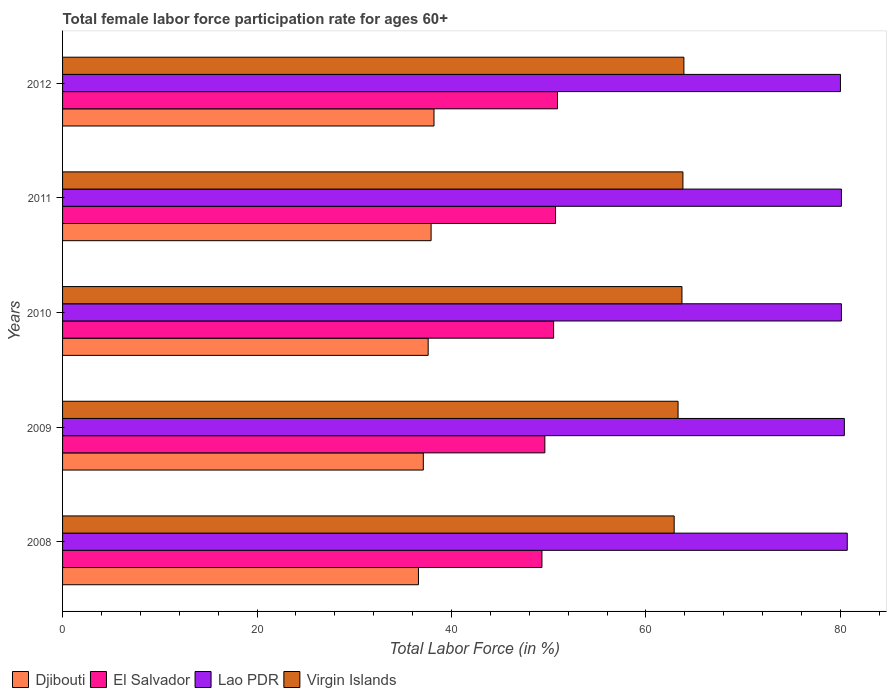How many groups of bars are there?
Ensure brevity in your answer.  5. Are the number of bars per tick equal to the number of legend labels?
Provide a succinct answer. Yes. What is the label of the 3rd group of bars from the top?
Give a very brief answer. 2010. What is the female labor force participation rate in Djibouti in 2009?
Make the answer very short. 37.1. Across all years, what is the maximum female labor force participation rate in Lao PDR?
Ensure brevity in your answer.  80.7. Across all years, what is the minimum female labor force participation rate in Virgin Islands?
Provide a short and direct response. 62.9. What is the total female labor force participation rate in Virgin Islands in the graph?
Ensure brevity in your answer.  317.6. What is the difference between the female labor force participation rate in El Salvador in 2010 and the female labor force participation rate in Lao PDR in 2009?
Make the answer very short. -29.9. What is the average female labor force participation rate in Djibouti per year?
Make the answer very short. 37.48. In the year 2009, what is the difference between the female labor force participation rate in Djibouti and female labor force participation rate in El Salvador?
Ensure brevity in your answer.  -12.5. What is the ratio of the female labor force participation rate in El Salvador in 2009 to that in 2012?
Your answer should be compact. 0.97. Is the female labor force participation rate in El Salvador in 2008 less than that in 2012?
Ensure brevity in your answer.  Yes. Is the difference between the female labor force participation rate in Djibouti in 2008 and 2011 greater than the difference between the female labor force participation rate in El Salvador in 2008 and 2011?
Ensure brevity in your answer.  Yes. What is the difference between the highest and the second highest female labor force participation rate in Djibouti?
Offer a very short reply. 0.3. What is the difference between the highest and the lowest female labor force participation rate in Djibouti?
Ensure brevity in your answer.  1.6. In how many years, is the female labor force participation rate in El Salvador greater than the average female labor force participation rate in El Salvador taken over all years?
Ensure brevity in your answer.  3. Is the sum of the female labor force participation rate in Djibouti in 2009 and 2010 greater than the maximum female labor force participation rate in El Salvador across all years?
Provide a succinct answer. Yes. Is it the case that in every year, the sum of the female labor force participation rate in Lao PDR and female labor force participation rate in Virgin Islands is greater than the sum of female labor force participation rate in Djibouti and female labor force participation rate in El Salvador?
Give a very brief answer. Yes. What does the 3rd bar from the top in 2009 represents?
Offer a very short reply. El Salvador. What does the 3rd bar from the bottom in 2008 represents?
Your response must be concise. Lao PDR. Is it the case that in every year, the sum of the female labor force participation rate in Virgin Islands and female labor force participation rate in Lao PDR is greater than the female labor force participation rate in Djibouti?
Offer a very short reply. Yes. How many bars are there?
Your answer should be very brief. 20. Are all the bars in the graph horizontal?
Your response must be concise. Yes. How many years are there in the graph?
Provide a succinct answer. 5. What is the difference between two consecutive major ticks on the X-axis?
Make the answer very short. 20. Does the graph contain grids?
Provide a succinct answer. No. What is the title of the graph?
Your answer should be compact. Total female labor force participation rate for ages 60+. What is the label or title of the X-axis?
Your answer should be compact. Total Labor Force (in %). What is the label or title of the Y-axis?
Your answer should be very brief. Years. What is the Total Labor Force (in %) in Djibouti in 2008?
Ensure brevity in your answer.  36.6. What is the Total Labor Force (in %) in El Salvador in 2008?
Provide a short and direct response. 49.3. What is the Total Labor Force (in %) in Lao PDR in 2008?
Your response must be concise. 80.7. What is the Total Labor Force (in %) of Virgin Islands in 2008?
Give a very brief answer. 62.9. What is the Total Labor Force (in %) of Djibouti in 2009?
Your answer should be very brief. 37.1. What is the Total Labor Force (in %) of El Salvador in 2009?
Ensure brevity in your answer.  49.6. What is the Total Labor Force (in %) of Lao PDR in 2009?
Provide a succinct answer. 80.4. What is the Total Labor Force (in %) of Virgin Islands in 2009?
Your response must be concise. 63.3. What is the Total Labor Force (in %) of Djibouti in 2010?
Your answer should be very brief. 37.6. What is the Total Labor Force (in %) in El Salvador in 2010?
Your response must be concise. 50.5. What is the Total Labor Force (in %) in Lao PDR in 2010?
Your response must be concise. 80.1. What is the Total Labor Force (in %) in Virgin Islands in 2010?
Make the answer very short. 63.7. What is the Total Labor Force (in %) of Djibouti in 2011?
Your answer should be very brief. 37.9. What is the Total Labor Force (in %) in El Salvador in 2011?
Ensure brevity in your answer.  50.7. What is the Total Labor Force (in %) in Lao PDR in 2011?
Ensure brevity in your answer.  80.1. What is the Total Labor Force (in %) in Virgin Islands in 2011?
Provide a short and direct response. 63.8. What is the Total Labor Force (in %) of Djibouti in 2012?
Give a very brief answer. 38.2. What is the Total Labor Force (in %) of El Salvador in 2012?
Ensure brevity in your answer.  50.9. What is the Total Labor Force (in %) of Virgin Islands in 2012?
Give a very brief answer. 63.9. Across all years, what is the maximum Total Labor Force (in %) in Djibouti?
Your answer should be very brief. 38.2. Across all years, what is the maximum Total Labor Force (in %) of El Salvador?
Provide a succinct answer. 50.9. Across all years, what is the maximum Total Labor Force (in %) in Lao PDR?
Your answer should be compact. 80.7. Across all years, what is the maximum Total Labor Force (in %) of Virgin Islands?
Keep it short and to the point. 63.9. Across all years, what is the minimum Total Labor Force (in %) in Djibouti?
Provide a short and direct response. 36.6. Across all years, what is the minimum Total Labor Force (in %) in El Salvador?
Provide a succinct answer. 49.3. Across all years, what is the minimum Total Labor Force (in %) of Virgin Islands?
Give a very brief answer. 62.9. What is the total Total Labor Force (in %) in Djibouti in the graph?
Give a very brief answer. 187.4. What is the total Total Labor Force (in %) in El Salvador in the graph?
Your response must be concise. 251. What is the total Total Labor Force (in %) of Lao PDR in the graph?
Make the answer very short. 401.3. What is the total Total Labor Force (in %) in Virgin Islands in the graph?
Offer a very short reply. 317.6. What is the difference between the Total Labor Force (in %) in Djibouti in 2008 and that in 2009?
Your answer should be very brief. -0.5. What is the difference between the Total Labor Force (in %) of El Salvador in 2008 and that in 2009?
Provide a short and direct response. -0.3. What is the difference between the Total Labor Force (in %) in Virgin Islands in 2008 and that in 2009?
Make the answer very short. -0.4. What is the difference between the Total Labor Force (in %) in El Salvador in 2008 and that in 2010?
Your answer should be very brief. -1.2. What is the difference between the Total Labor Force (in %) of Djibouti in 2008 and that in 2011?
Give a very brief answer. -1.3. What is the difference between the Total Labor Force (in %) in Djibouti in 2008 and that in 2012?
Make the answer very short. -1.6. What is the difference between the Total Labor Force (in %) of El Salvador in 2009 and that in 2010?
Make the answer very short. -0.9. What is the difference between the Total Labor Force (in %) of Lao PDR in 2009 and that in 2010?
Make the answer very short. 0.3. What is the difference between the Total Labor Force (in %) in El Salvador in 2009 and that in 2012?
Your answer should be very brief. -1.3. What is the difference between the Total Labor Force (in %) in Lao PDR in 2009 and that in 2012?
Your response must be concise. 0.4. What is the difference between the Total Labor Force (in %) in Virgin Islands in 2009 and that in 2012?
Provide a succinct answer. -0.6. What is the difference between the Total Labor Force (in %) of El Salvador in 2010 and that in 2011?
Ensure brevity in your answer.  -0.2. What is the difference between the Total Labor Force (in %) of Lao PDR in 2010 and that in 2012?
Your answer should be compact. 0.1. What is the difference between the Total Labor Force (in %) in El Salvador in 2011 and that in 2012?
Give a very brief answer. -0.2. What is the difference between the Total Labor Force (in %) of Lao PDR in 2011 and that in 2012?
Provide a short and direct response. 0.1. What is the difference between the Total Labor Force (in %) of Djibouti in 2008 and the Total Labor Force (in %) of Lao PDR in 2009?
Offer a very short reply. -43.8. What is the difference between the Total Labor Force (in %) of Djibouti in 2008 and the Total Labor Force (in %) of Virgin Islands in 2009?
Provide a short and direct response. -26.7. What is the difference between the Total Labor Force (in %) of El Salvador in 2008 and the Total Labor Force (in %) of Lao PDR in 2009?
Your answer should be very brief. -31.1. What is the difference between the Total Labor Force (in %) in El Salvador in 2008 and the Total Labor Force (in %) in Virgin Islands in 2009?
Ensure brevity in your answer.  -14. What is the difference between the Total Labor Force (in %) in Djibouti in 2008 and the Total Labor Force (in %) in El Salvador in 2010?
Give a very brief answer. -13.9. What is the difference between the Total Labor Force (in %) in Djibouti in 2008 and the Total Labor Force (in %) in Lao PDR in 2010?
Your answer should be very brief. -43.5. What is the difference between the Total Labor Force (in %) in Djibouti in 2008 and the Total Labor Force (in %) in Virgin Islands in 2010?
Provide a succinct answer. -27.1. What is the difference between the Total Labor Force (in %) in El Salvador in 2008 and the Total Labor Force (in %) in Lao PDR in 2010?
Keep it short and to the point. -30.8. What is the difference between the Total Labor Force (in %) in El Salvador in 2008 and the Total Labor Force (in %) in Virgin Islands in 2010?
Your response must be concise. -14.4. What is the difference between the Total Labor Force (in %) of Lao PDR in 2008 and the Total Labor Force (in %) of Virgin Islands in 2010?
Keep it short and to the point. 17. What is the difference between the Total Labor Force (in %) of Djibouti in 2008 and the Total Labor Force (in %) of El Salvador in 2011?
Ensure brevity in your answer.  -14.1. What is the difference between the Total Labor Force (in %) of Djibouti in 2008 and the Total Labor Force (in %) of Lao PDR in 2011?
Your answer should be compact. -43.5. What is the difference between the Total Labor Force (in %) in Djibouti in 2008 and the Total Labor Force (in %) in Virgin Islands in 2011?
Your answer should be compact. -27.2. What is the difference between the Total Labor Force (in %) in El Salvador in 2008 and the Total Labor Force (in %) in Lao PDR in 2011?
Provide a short and direct response. -30.8. What is the difference between the Total Labor Force (in %) of El Salvador in 2008 and the Total Labor Force (in %) of Virgin Islands in 2011?
Give a very brief answer. -14.5. What is the difference between the Total Labor Force (in %) of Djibouti in 2008 and the Total Labor Force (in %) of El Salvador in 2012?
Make the answer very short. -14.3. What is the difference between the Total Labor Force (in %) of Djibouti in 2008 and the Total Labor Force (in %) of Lao PDR in 2012?
Offer a very short reply. -43.4. What is the difference between the Total Labor Force (in %) of Djibouti in 2008 and the Total Labor Force (in %) of Virgin Islands in 2012?
Give a very brief answer. -27.3. What is the difference between the Total Labor Force (in %) of El Salvador in 2008 and the Total Labor Force (in %) of Lao PDR in 2012?
Your response must be concise. -30.7. What is the difference between the Total Labor Force (in %) of El Salvador in 2008 and the Total Labor Force (in %) of Virgin Islands in 2012?
Provide a short and direct response. -14.6. What is the difference between the Total Labor Force (in %) of Lao PDR in 2008 and the Total Labor Force (in %) of Virgin Islands in 2012?
Offer a very short reply. 16.8. What is the difference between the Total Labor Force (in %) of Djibouti in 2009 and the Total Labor Force (in %) of Lao PDR in 2010?
Give a very brief answer. -43. What is the difference between the Total Labor Force (in %) in Djibouti in 2009 and the Total Labor Force (in %) in Virgin Islands in 2010?
Provide a short and direct response. -26.6. What is the difference between the Total Labor Force (in %) of El Salvador in 2009 and the Total Labor Force (in %) of Lao PDR in 2010?
Provide a succinct answer. -30.5. What is the difference between the Total Labor Force (in %) in El Salvador in 2009 and the Total Labor Force (in %) in Virgin Islands in 2010?
Offer a very short reply. -14.1. What is the difference between the Total Labor Force (in %) of Lao PDR in 2009 and the Total Labor Force (in %) of Virgin Islands in 2010?
Ensure brevity in your answer.  16.7. What is the difference between the Total Labor Force (in %) of Djibouti in 2009 and the Total Labor Force (in %) of El Salvador in 2011?
Make the answer very short. -13.6. What is the difference between the Total Labor Force (in %) of Djibouti in 2009 and the Total Labor Force (in %) of Lao PDR in 2011?
Give a very brief answer. -43. What is the difference between the Total Labor Force (in %) in Djibouti in 2009 and the Total Labor Force (in %) in Virgin Islands in 2011?
Give a very brief answer. -26.7. What is the difference between the Total Labor Force (in %) in El Salvador in 2009 and the Total Labor Force (in %) in Lao PDR in 2011?
Give a very brief answer. -30.5. What is the difference between the Total Labor Force (in %) of Lao PDR in 2009 and the Total Labor Force (in %) of Virgin Islands in 2011?
Keep it short and to the point. 16.6. What is the difference between the Total Labor Force (in %) in Djibouti in 2009 and the Total Labor Force (in %) in Lao PDR in 2012?
Offer a terse response. -42.9. What is the difference between the Total Labor Force (in %) in Djibouti in 2009 and the Total Labor Force (in %) in Virgin Islands in 2012?
Offer a terse response. -26.8. What is the difference between the Total Labor Force (in %) in El Salvador in 2009 and the Total Labor Force (in %) in Lao PDR in 2012?
Keep it short and to the point. -30.4. What is the difference between the Total Labor Force (in %) of El Salvador in 2009 and the Total Labor Force (in %) of Virgin Islands in 2012?
Ensure brevity in your answer.  -14.3. What is the difference between the Total Labor Force (in %) in Djibouti in 2010 and the Total Labor Force (in %) in El Salvador in 2011?
Keep it short and to the point. -13.1. What is the difference between the Total Labor Force (in %) in Djibouti in 2010 and the Total Labor Force (in %) in Lao PDR in 2011?
Provide a short and direct response. -42.5. What is the difference between the Total Labor Force (in %) of Djibouti in 2010 and the Total Labor Force (in %) of Virgin Islands in 2011?
Give a very brief answer. -26.2. What is the difference between the Total Labor Force (in %) of El Salvador in 2010 and the Total Labor Force (in %) of Lao PDR in 2011?
Your answer should be compact. -29.6. What is the difference between the Total Labor Force (in %) of Lao PDR in 2010 and the Total Labor Force (in %) of Virgin Islands in 2011?
Your answer should be compact. 16.3. What is the difference between the Total Labor Force (in %) in Djibouti in 2010 and the Total Labor Force (in %) in Lao PDR in 2012?
Your response must be concise. -42.4. What is the difference between the Total Labor Force (in %) in Djibouti in 2010 and the Total Labor Force (in %) in Virgin Islands in 2012?
Provide a succinct answer. -26.3. What is the difference between the Total Labor Force (in %) of El Salvador in 2010 and the Total Labor Force (in %) of Lao PDR in 2012?
Provide a short and direct response. -29.5. What is the difference between the Total Labor Force (in %) in El Salvador in 2010 and the Total Labor Force (in %) in Virgin Islands in 2012?
Keep it short and to the point. -13.4. What is the difference between the Total Labor Force (in %) in Lao PDR in 2010 and the Total Labor Force (in %) in Virgin Islands in 2012?
Keep it short and to the point. 16.2. What is the difference between the Total Labor Force (in %) in Djibouti in 2011 and the Total Labor Force (in %) in Lao PDR in 2012?
Offer a terse response. -42.1. What is the difference between the Total Labor Force (in %) in Djibouti in 2011 and the Total Labor Force (in %) in Virgin Islands in 2012?
Provide a short and direct response. -26. What is the difference between the Total Labor Force (in %) of El Salvador in 2011 and the Total Labor Force (in %) of Lao PDR in 2012?
Keep it short and to the point. -29.3. What is the difference between the Total Labor Force (in %) in El Salvador in 2011 and the Total Labor Force (in %) in Virgin Islands in 2012?
Make the answer very short. -13.2. What is the average Total Labor Force (in %) in Djibouti per year?
Your answer should be compact. 37.48. What is the average Total Labor Force (in %) in El Salvador per year?
Your answer should be very brief. 50.2. What is the average Total Labor Force (in %) of Lao PDR per year?
Your answer should be very brief. 80.26. What is the average Total Labor Force (in %) in Virgin Islands per year?
Keep it short and to the point. 63.52. In the year 2008, what is the difference between the Total Labor Force (in %) of Djibouti and Total Labor Force (in %) of Lao PDR?
Offer a terse response. -44.1. In the year 2008, what is the difference between the Total Labor Force (in %) of Djibouti and Total Labor Force (in %) of Virgin Islands?
Offer a terse response. -26.3. In the year 2008, what is the difference between the Total Labor Force (in %) of El Salvador and Total Labor Force (in %) of Lao PDR?
Provide a succinct answer. -31.4. In the year 2008, what is the difference between the Total Labor Force (in %) of El Salvador and Total Labor Force (in %) of Virgin Islands?
Give a very brief answer. -13.6. In the year 2009, what is the difference between the Total Labor Force (in %) in Djibouti and Total Labor Force (in %) in Lao PDR?
Offer a terse response. -43.3. In the year 2009, what is the difference between the Total Labor Force (in %) in Djibouti and Total Labor Force (in %) in Virgin Islands?
Your answer should be very brief. -26.2. In the year 2009, what is the difference between the Total Labor Force (in %) of El Salvador and Total Labor Force (in %) of Lao PDR?
Provide a succinct answer. -30.8. In the year 2009, what is the difference between the Total Labor Force (in %) of El Salvador and Total Labor Force (in %) of Virgin Islands?
Provide a succinct answer. -13.7. In the year 2009, what is the difference between the Total Labor Force (in %) in Lao PDR and Total Labor Force (in %) in Virgin Islands?
Provide a short and direct response. 17.1. In the year 2010, what is the difference between the Total Labor Force (in %) in Djibouti and Total Labor Force (in %) in El Salvador?
Keep it short and to the point. -12.9. In the year 2010, what is the difference between the Total Labor Force (in %) of Djibouti and Total Labor Force (in %) of Lao PDR?
Your response must be concise. -42.5. In the year 2010, what is the difference between the Total Labor Force (in %) of Djibouti and Total Labor Force (in %) of Virgin Islands?
Your answer should be compact. -26.1. In the year 2010, what is the difference between the Total Labor Force (in %) of El Salvador and Total Labor Force (in %) of Lao PDR?
Your response must be concise. -29.6. In the year 2010, what is the difference between the Total Labor Force (in %) in Lao PDR and Total Labor Force (in %) in Virgin Islands?
Provide a succinct answer. 16.4. In the year 2011, what is the difference between the Total Labor Force (in %) of Djibouti and Total Labor Force (in %) of Lao PDR?
Give a very brief answer. -42.2. In the year 2011, what is the difference between the Total Labor Force (in %) of Djibouti and Total Labor Force (in %) of Virgin Islands?
Your response must be concise. -25.9. In the year 2011, what is the difference between the Total Labor Force (in %) of El Salvador and Total Labor Force (in %) of Lao PDR?
Keep it short and to the point. -29.4. In the year 2011, what is the difference between the Total Labor Force (in %) of Lao PDR and Total Labor Force (in %) of Virgin Islands?
Your response must be concise. 16.3. In the year 2012, what is the difference between the Total Labor Force (in %) of Djibouti and Total Labor Force (in %) of El Salvador?
Your answer should be very brief. -12.7. In the year 2012, what is the difference between the Total Labor Force (in %) in Djibouti and Total Labor Force (in %) in Lao PDR?
Offer a terse response. -41.8. In the year 2012, what is the difference between the Total Labor Force (in %) in Djibouti and Total Labor Force (in %) in Virgin Islands?
Provide a short and direct response. -25.7. In the year 2012, what is the difference between the Total Labor Force (in %) in El Salvador and Total Labor Force (in %) in Lao PDR?
Your answer should be very brief. -29.1. In the year 2012, what is the difference between the Total Labor Force (in %) in El Salvador and Total Labor Force (in %) in Virgin Islands?
Provide a succinct answer. -13. In the year 2012, what is the difference between the Total Labor Force (in %) in Lao PDR and Total Labor Force (in %) in Virgin Islands?
Offer a terse response. 16.1. What is the ratio of the Total Labor Force (in %) in Djibouti in 2008 to that in 2009?
Offer a very short reply. 0.99. What is the ratio of the Total Labor Force (in %) in Virgin Islands in 2008 to that in 2009?
Offer a terse response. 0.99. What is the ratio of the Total Labor Force (in %) in Djibouti in 2008 to that in 2010?
Your answer should be compact. 0.97. What is the ratio of the Total Labor Force (in %) in El Salvador in 2008 to that in 2010?
Your answer should be very brief. 0.98. What is the ratio of the Total Labor Force (in %) in Lao PDR in 2008 to that in 2010?
Provide a succinct answer. 1.01. What is the ratio of the Total Labor Force (in %) of Virgin Islands in 2008 to that in 2010?
Offer a very short reply. 0.99. What is the ratio of the Total Labor Force (in %) in Djibouti in 2008 to that in 2011?
Offer a very short reply. 0.97. What is the ratio of the Total Labor Force (in %) in El Salvador in 2008 to that in 2011?
Give a very brief answer. 0.97. What is the ratio of the Total Labor Force (in %) of Lao PDR in 2008 to that in 2011?
Offer a terse response. 1.01. What is the ratio of the Total Labor Force (in %) of Virgin Islands in 2008 to that in 2011?
Give a very brief answer. 0.99. What is the ratio of the Total Labor Force (in %) of Djibouti in 2008 to that in 2012?
Ensure brevity in your answer.  0.96. What is the ratio of the Total Labor Force (in %) of El Salvador in 2008 to that in 2012?
Give a very brief answer. 0.97. What is the ratio of the Total Labor Force (in %) of Lao PDR in 2008 to that in 2012?
Make the answer very short. 1.01. What is the ratio of the Total Labor Force (in %) of Virgin Islands in 2008 to that in 2012?
Offer a very short reply. 0.98. What is the ratio of the Total Labor Force (in %) in Djibouti in 2009 to that in 2010?
Your response must be concise. 0.99. What is the ratio of the Total Labor Force (in %) of El Salvador in 2009 to that in 2010?
Keep it short and to the point. 0.98. What is the ratio of the Total Labor Force (in %) of Lao PDR in 2009 to that in 2010?
Provide a succinct answer. 1. What is the ratio of the Total Labor Force (in %) in Virgin Islands in 2009 to that in 2010?
Your response must be concise. 0.99. What is the ratio of the Total Labor Force (in %) in Djibouti in 2009 to that in 2011?
Provide a short and direct response. 0.98. What is the ratio of the Total Labor Force (in %) of El Salvador in 2009 to that in 2011?
Your response must be concise. 0.98. What is the ratio of the Total Labor Force (in %) of Virgin Islands in 2009 to that in 2011?
Provide a short and direct response. 0.99. What is the ratio of the Total Labor Force (in %) in Djibouti in 2009 to that in 2012?
Ensure brevity in your answer.  0.97. What is the ratio of the Total Labor Force (in %) in El Salvador in 2009 to that in 2012?
Offer a very short reply. 0.97. What is the ratio of the Total Labor Force (in %) in Virgin Islands in 2009 to that in 2012?
Offer a very short reply. 0.99. What is the ratio of the Total Labor Force (in %) of Djibouti in 2010 to that in 2011?
Your answer should be very brief. 0.99. What is the ratio of the Total Labor Force (in %) in El Salvador in 2010 to that in 2011?
Provide a succinct answer. 1. What is the ratio of the Total Labor Force (in %) of Djibouti in 2010 to that in 2012?
Provide a short and direct response. 0.98. What is the ratio of the Total Labor Force (in %) in El Salvador in 2010 to that in 2012?
Provide a succinct answer. 0.99. What is the ratio of the Total Labor Force (in %) in Lao PDR in 2010 to that in 2012?
Keep it short and to the point. 1. What is the ratio of the Total Labor Force (in %) in Virgin Islands in 2010 to that in 2012?
Provide a short and direct response. 1. What is the ratio of the Total Labor Force (in %) of Djibouti in 2011 to that in 2012?
Keep it short and to the point. 0.99. What is the ratio of the Total Labor Force (in %) in El Salvador in 2011 to that in 2012?
Offer a very short reply. 1. What is the ratio of the Total Labor Force (in %) of Lao PDR in 2011 to that in 2012?
Keep it short and to the point. 1. What is the ratio of the Total Labor Force (in %) of Virgin Islands in 2011 to that in 2012?
Give a very brief answer. 1. What is the difference between the highest and the second highest Total Labor Force (in %) of Djibouti?
Offer a very short reply. 0.3. What is the difference between the highest and the second highest Total Labor Force (in %) of El Salvador?
Keep it short and to the point. 0.2. What is the difference between the highest and the second highest Total Labor Force (in %) of Lao PDR?
Ensure brevity in your answer.  0.3. What is the difference between the highest and the second highest Total Labor Force (in %) of Virgin Islands?
Give a very brief answer. 0.1. What is the difference between the highest and the lowest Total Labor Force (in %) in Lao PDR?
Give a very brief answer. 0.7. What is the difference between the highest and the lowest Total Labor Force (in %) in Virgin Islands?
Your response must be concise. 1. 